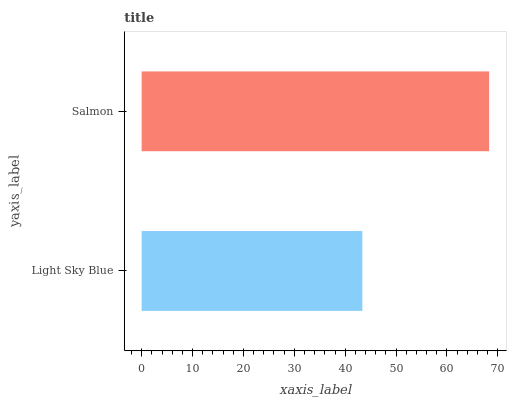Is Light Sky Blue the minimum?
Answer yes or no. Yes. Is Salmon the maximum?
Answer yes or no. Yes. Is Salmon the minimum?
Answer yes or no. No. Is Salmon greater than Light Sky Blue?
Answer yes or no. Yes. Is Light Sky Blue less than Salmon?
Answer yes or no. Yes. Is Light Sky Blue greater than Salmon?
Answer yes or no. No. Is Salmon less than Light Sky Blue?
Answer yes or no. No. Is Salmon the high median?
Answer yes or no. Yes. Is Light Sky Blue the low median?
Answer yes or no. Yes. Is Light Sky Blue the high median?
Answer yes or no. No. Is Salmon the low median?
Answer yes or no. No. 